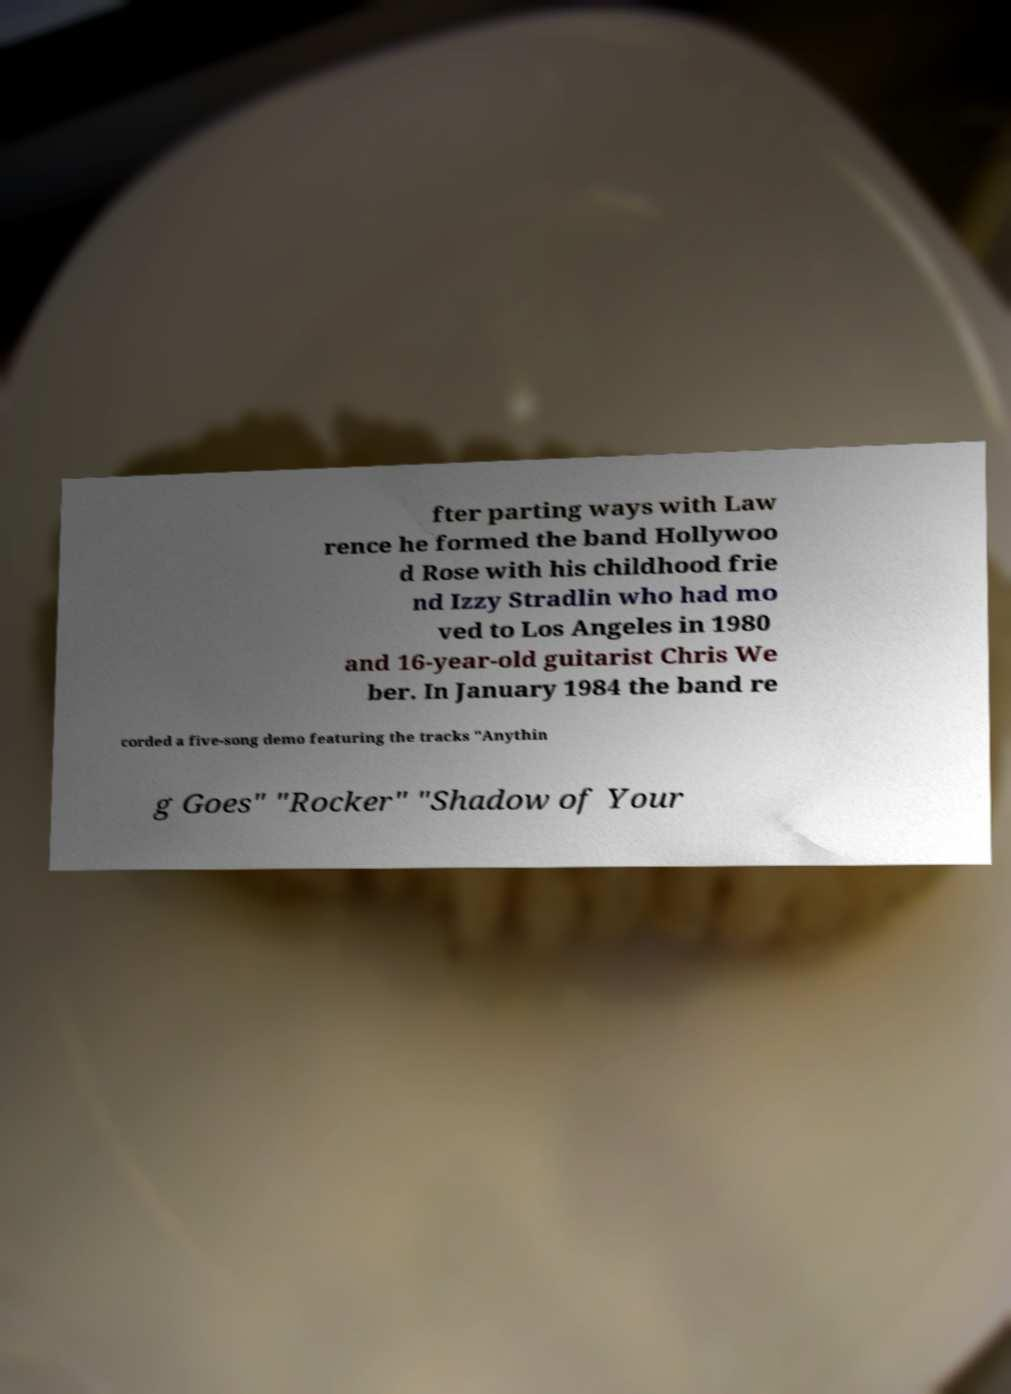What messages or text are displayed in this image? I need them in a readable, typed format. fter parting ways with Law rence he formed the band Hollywoo d Rose with his childhood frie nd Izzy Stradlin who had mo ved to Los Angeles in 1980 and 16-year-old guitarist Chris We ber. In January 1984 the band re corded a five-song demo featuring the tracks "Anythin g Goes" "Rocker" "Shadow of Your 